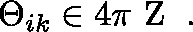Convert formula to latex. <formula><loc_0><loc_0><loc_500><loc_500>\Theta _ { i k } \in 4 \pi { \boldmath Z } \, .</formula> 